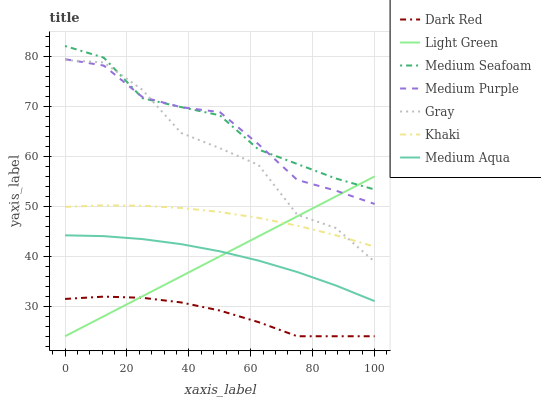Does Dark Red have the minimum area under the curve?
Answer yes or no. Yes. Does Medium Seafoam have the maximum area under the curve?
Answer yes or no. Yes. Does Khaki have the minimum area under the curve?
Answer yes or no. No. Does Khaki have the maximum area under the curve?
Answer yes or no. No. Is Light Green the smoothest?
Answer yes or no. Yes. Is Gray the roughest?
Answer yes or no. Yes. Is Khaki the smoothest?
Answer yes or no. No. Is Khaki the roughest?
Answer yes or no. No. Does Dark Red have the lowest value?
Answer yes or no. Yes. Does Khaki have the lowest value?
Answer yes or no. No. Does Medium Seafoam have the highest value?
Answer yes or no. Yes. Does Khaki have the highest value?
Answer yes or no. No. Is Khaki less than Medium Purple?
Answer yes or no. Yes. Is Medium Aqua greater than Dark Red?
Answer yes or no. Yes. Does Dark Red intersect Light Green?
Answer yes or no. Yes. Is Dark Red less than Light Green?
Answer yes or no. No. Is Dark Red greater than Light Green?
Answer yes or no. No. Does Khaki intersect Medium Purple?
Answer yes or no. No. 